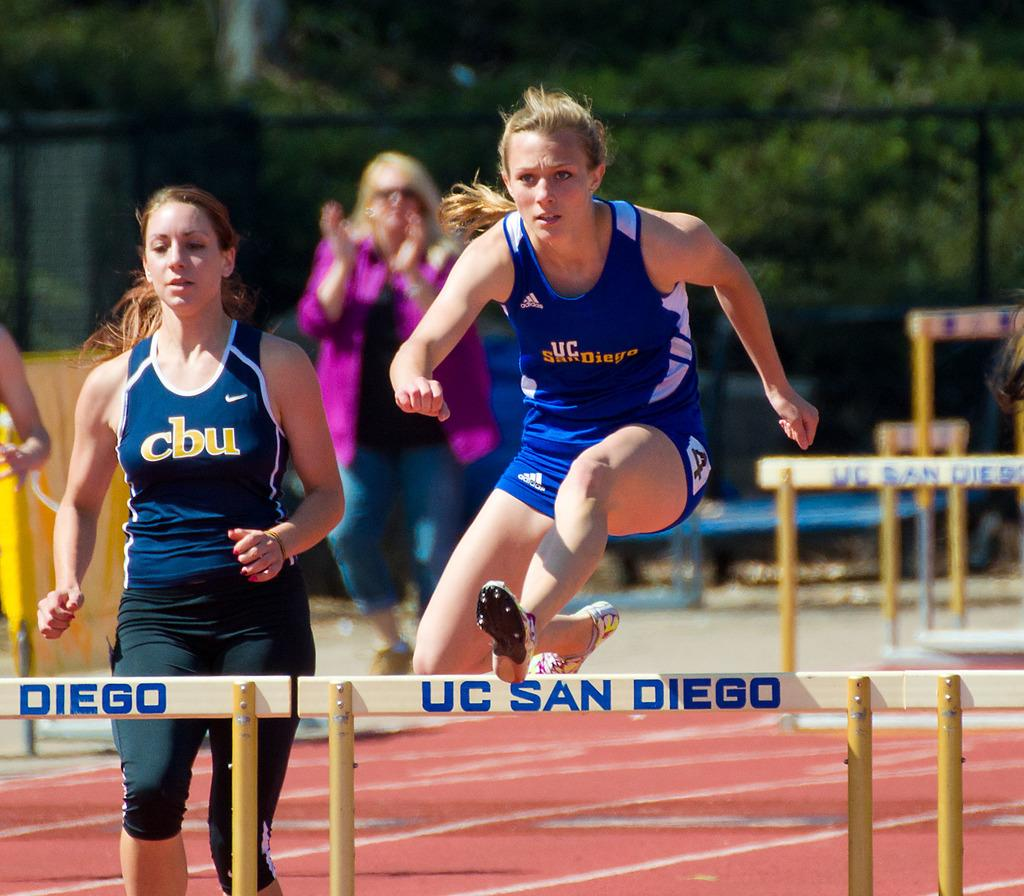Provide a one-sentence caption for the provided image. A runner jumps over a hurdle that says UC San Diego on it. 